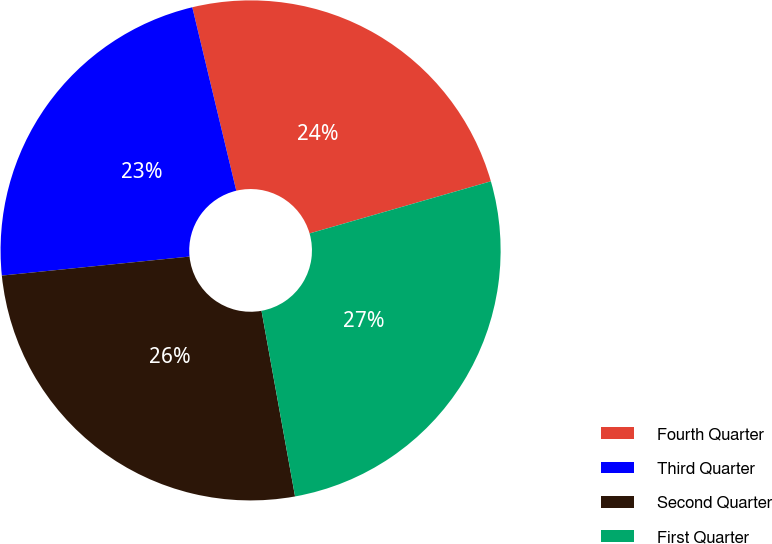Convert chart. <chart><loc_0><loc_0><loc_500><loc_500><pie_chart><fcel>Fourth Quarter<fcel>Third Quarter<fcel>Second Quarter<fcel>First Quarter<nl><fcel>24.29%<fcel>22.86%<fcel>26.24%<fcel>26.61%<nl></chart> 